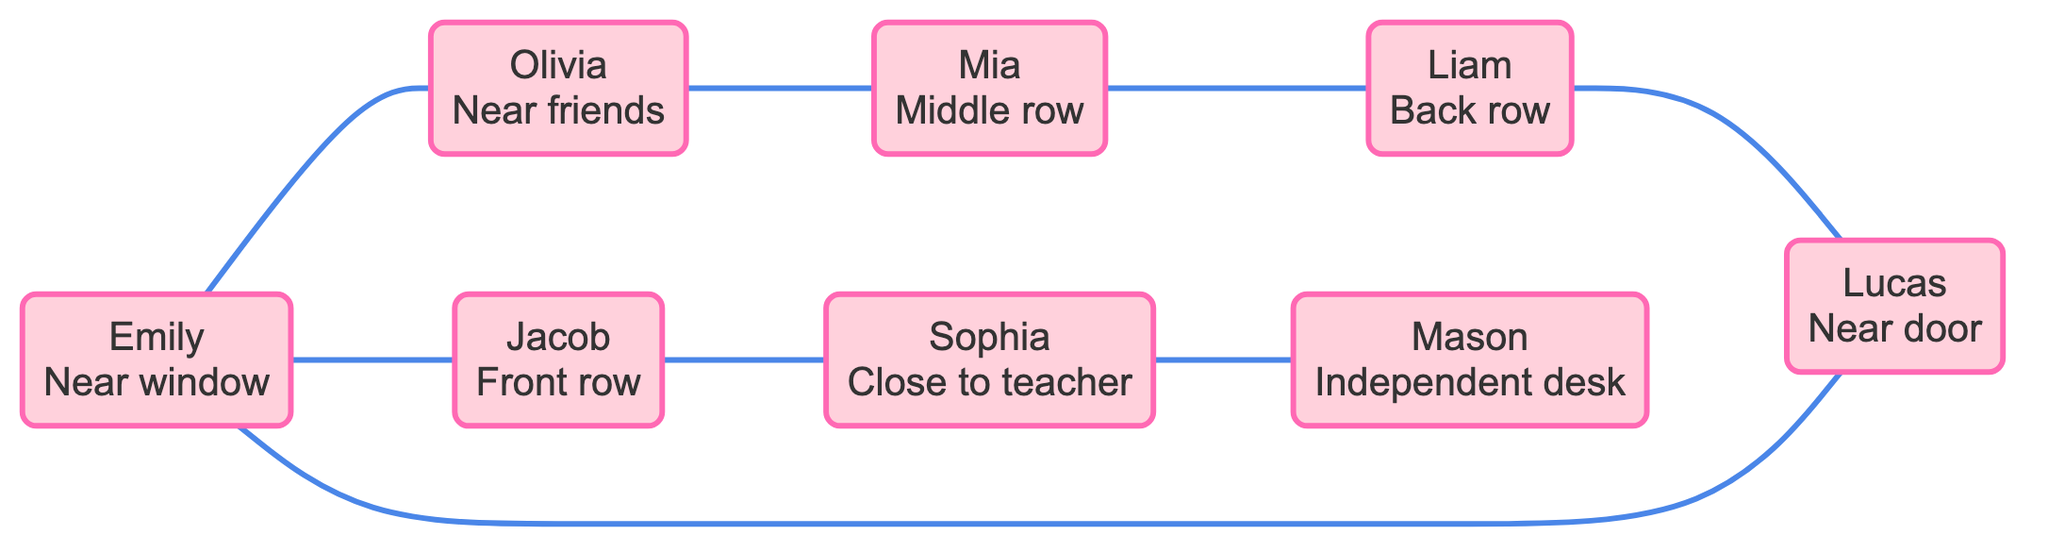What seating preference does Emily have? The diagram states that Emily's preference is "Near window," which is displayed within the node representing her.
Answer: Near window How many students are represented in the diagram? There are eight nodes, each representing a student, indicating that eight students are represented in the diagram.
Answer: 8 Which student prefers the front row? The node for Jacob shows that his preference is "Front row." Therefore, Jacob is the student who prefers this seating arrangement.
Answer: Jacob What is the relationship between Liam and Lucas? The edge between Liam and Lucas indicates that Liam "prefers back," and the relationship specifies their preference connection in terms of seating.
Answer: prefers back Which student is connected to both Emily and Sophia? Tracing the edges from both Emily and Sophia leads to Jacob, who is connected to both students. This means Jacob is the common student connected to Emily and Sophia in the diagram.
Answer: Jacob How many total edges are shown in the graph? The edges depict the relationships between students; there are eight edges connecting the students in the graph.
Answer: 8 Which two students prefer middle seating? The nodes show that both Olivia and Mia prefer "middle," confirming that they share this seating preference.
Answer: Olivia, Mia Which student has a preference for an independent desk? In the diagram, Mason is specifically noted to prefer an "Independent desk," highlighting his unique seating choice compared to others.
Answer: Mason What relationship does Jacob have with Sophia? The edge connecting Jacob and Sophia specifies that Jacob "prefers front," indicating their distinct preference relationship in seating arrangements.
Answer: prefers front 